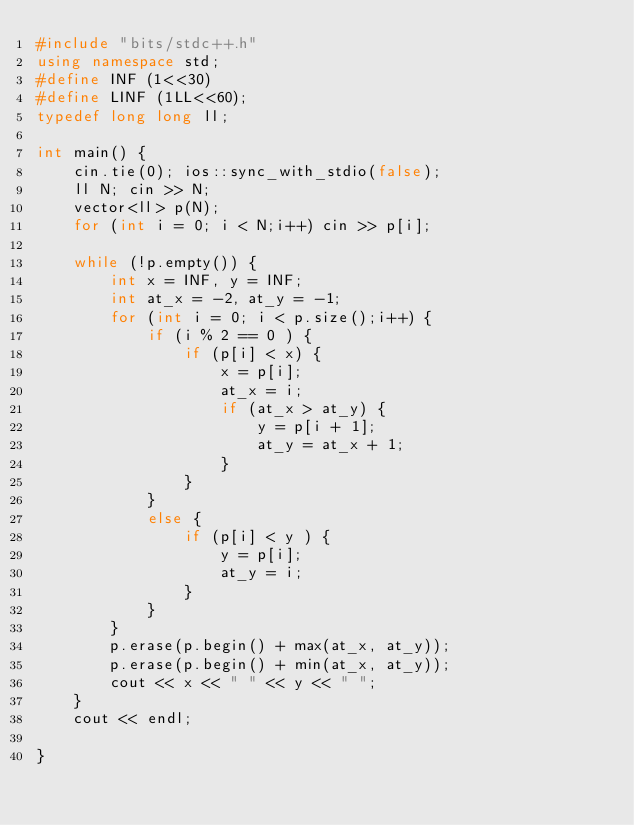<code> <loc_0><loc_0><loc_500><loc_500><_C++_>#include "bits/stdc++.h"
using namespace std;
#define INF (1<<30)
#define LINF (1LL<<60);
typedef long long ll;

int main() {
	cin.tie(0); ios::sync_with_stdio(false);
	ll N; cin >> N;
	vector<ll> p(N);
	for (int i = 0; i < N;i++) cin >> p[i];

	while (!p.empty()) {
		int x = INF, y = INF;
		int at_x = -2, at_y = -1;
		for (int i = 0; i < p.size();i++) {
			if (i % 2 == 0 ) {
				if (p[i] < x) {
					x = p[i];
					at_x = i;
					if (at_x > at_y) {
						y = p[i + 1];
						at_y = at_x + 1;
					}
				}
			}
			else {
				if (p[i] < y ) {
					y = p[i];
					at_y = i;
				}
			}
		}
		p.erase(p.begin() + max(at_x, at_y));
		p.erase(p.begin() + min(at_x, at_y));
		cout << x << " " << y << " ";
	}
	cout << endl;

}</code> 